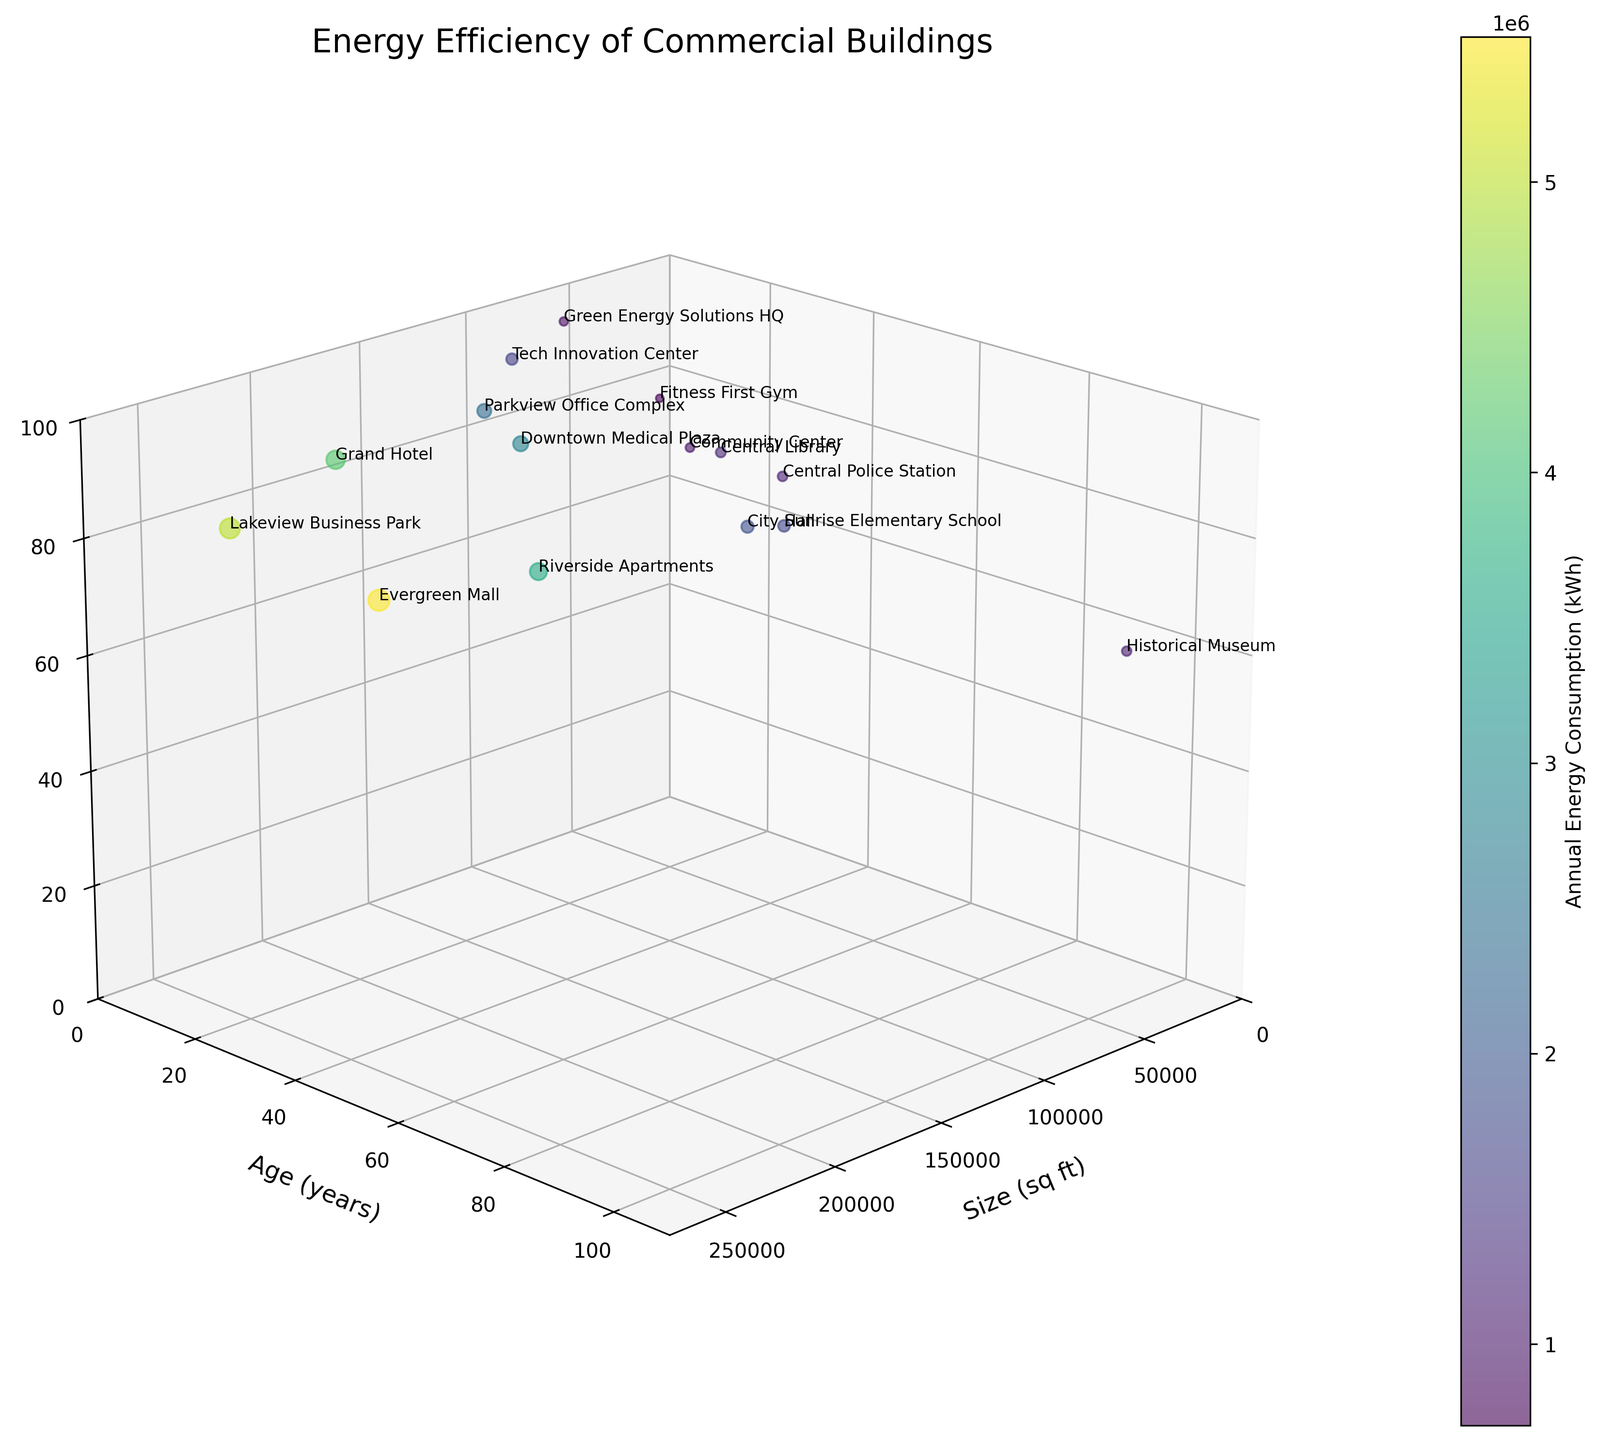What is the title of the 3D bubble chart? The title is displayed at the top of the figure, it reads "Energy Efficiency of Commercial Buildings"
Answer: Energy Efficiency of Commercial Buildings How many buildings have energy efficiency ratings above 80? Look at the z-axis labeling and count the number of bubbles that are positioned above 80 on this axis
Answer: 6 Which building type tends to have the largest annual energy consumption? Identify the coloring and size of bubbles corresponding to different building types, larger and darker bubbles indicate higher annual consumption
Answer: Retail What is the energy efficiency rating of the newest building? Find the bubble with the lowest y-axis value (Age in Years) and read the corresponding z-axis value (Energy Efficiency Rating)
Answer: 95 Are there more buildings with an age above 30 years or below 30 years? Count the bubbles on the y-axis above and below the 30-year mark
Answer: Below 30 years Which building has the largest square footage? Identify the x-axis (Size in SqFt) and find the bubble farthest to the right
Answer: Lakeview Business Park What is the average energy efficiency rating of buildings with over 150,000 sq ft? Identify the bubbles on the x-axis over 150,000 sq ft, then calculate their average energy efficiency rating
Answer: (68 + 84 + 85)/3 = 79 Which building has the highest annual energy consumption and what is its energy efficiency rating? Look for the largest and darkest bubble and check its corresponding z-axis value
Answer: Evergreen Mall, 68 What is the observed relationship between the age of a building and its energy efficiency rating? Analyze the distribution along the y-axis (Age) to z-axis (Energy Efficiency Rating) and identify if there's an increasing or decreasing trend
Answer: Older buildings tend to have lower energy efficiency ratings 